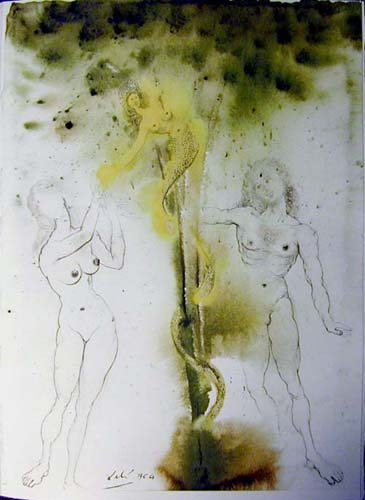Can you describe the main features of this image for me? The image features a compelling surrealistic tableau with three humanoid figures, each sketched in stark black outlines against a mystically infused backdrop of green and yellow hues. The central figure clings to a serpentine plant-like form, which serves as both a literal and figural lifeline, weaving through the composition. The use of nudity emphasizes the raw, unshielded essence of the figures, linking them to themes of vulnerability and human nature. The background, speckled with black, creates a sense of depth and adds a textural quality that complements the ethereal atmosphere. This artwork intriguingly blends elements of fantasy with a poignant exploration of the human condition. 